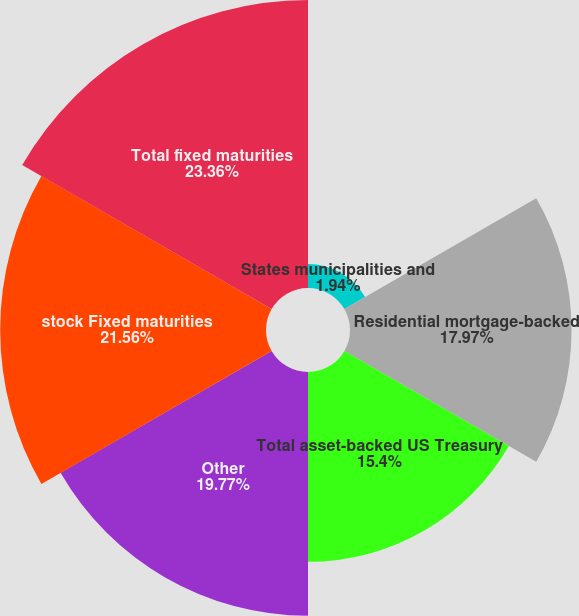Convert chart to OTSL. <chart><loc_0><loc_0><loc_500><loc_500><pie_chart><fcel>States municipalities and<fcel>Residential mortgage-backed<fcel>Total asset-backed US Treasury<fcel>Other<fcel>stock Fixed maturities<fcel>Total fixed maturities<nl><fcel>1.94%<fcel>17.97%<fcel>15.4%<fcel>19.77%<fcel>21.56%<fcel>23.36%<nl></chart> 